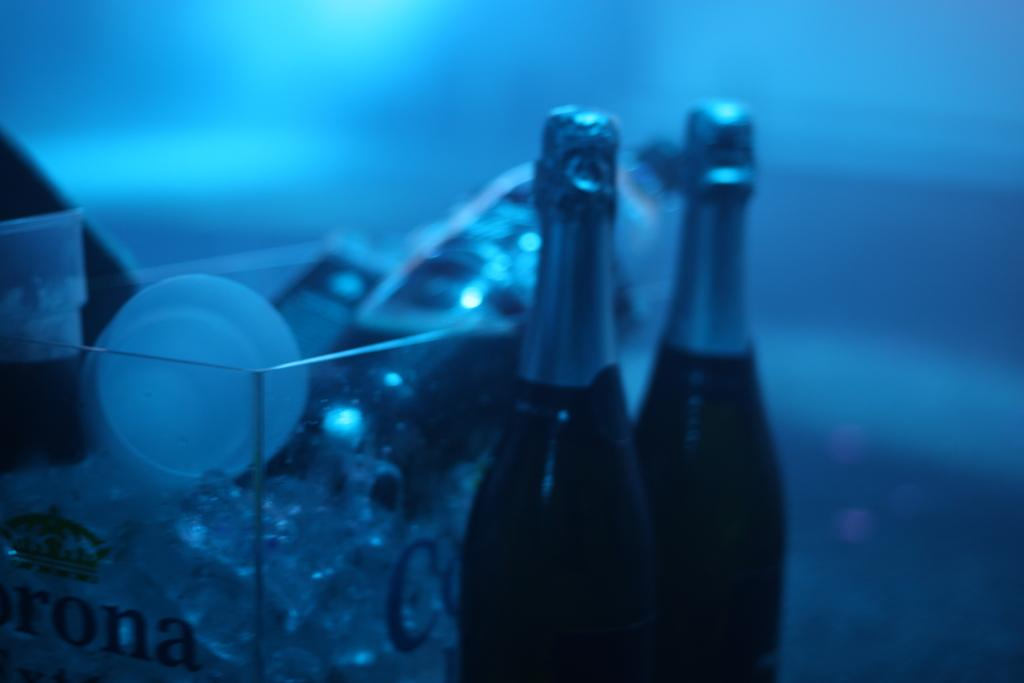<image>
Render a clear and concise summary of the photo. Two wine bottles sit beside a clear case that says rona on it. 